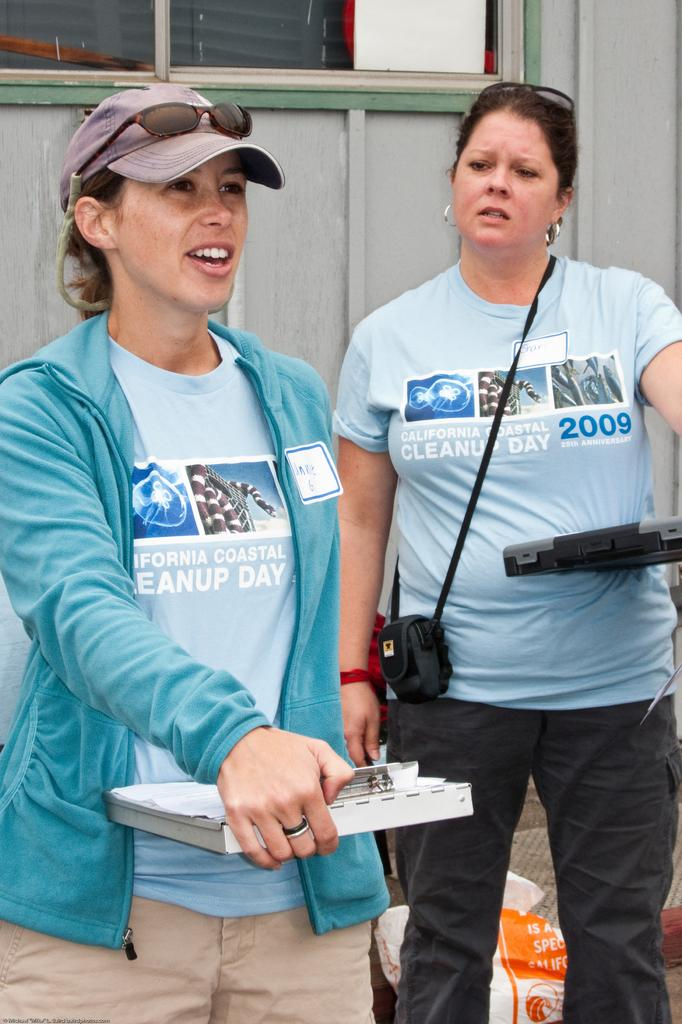<image>
Relay a brief, clear account of the picture shown. Two women are wearing shirts that say California Coastal Cleanup Day and have clipboards. 